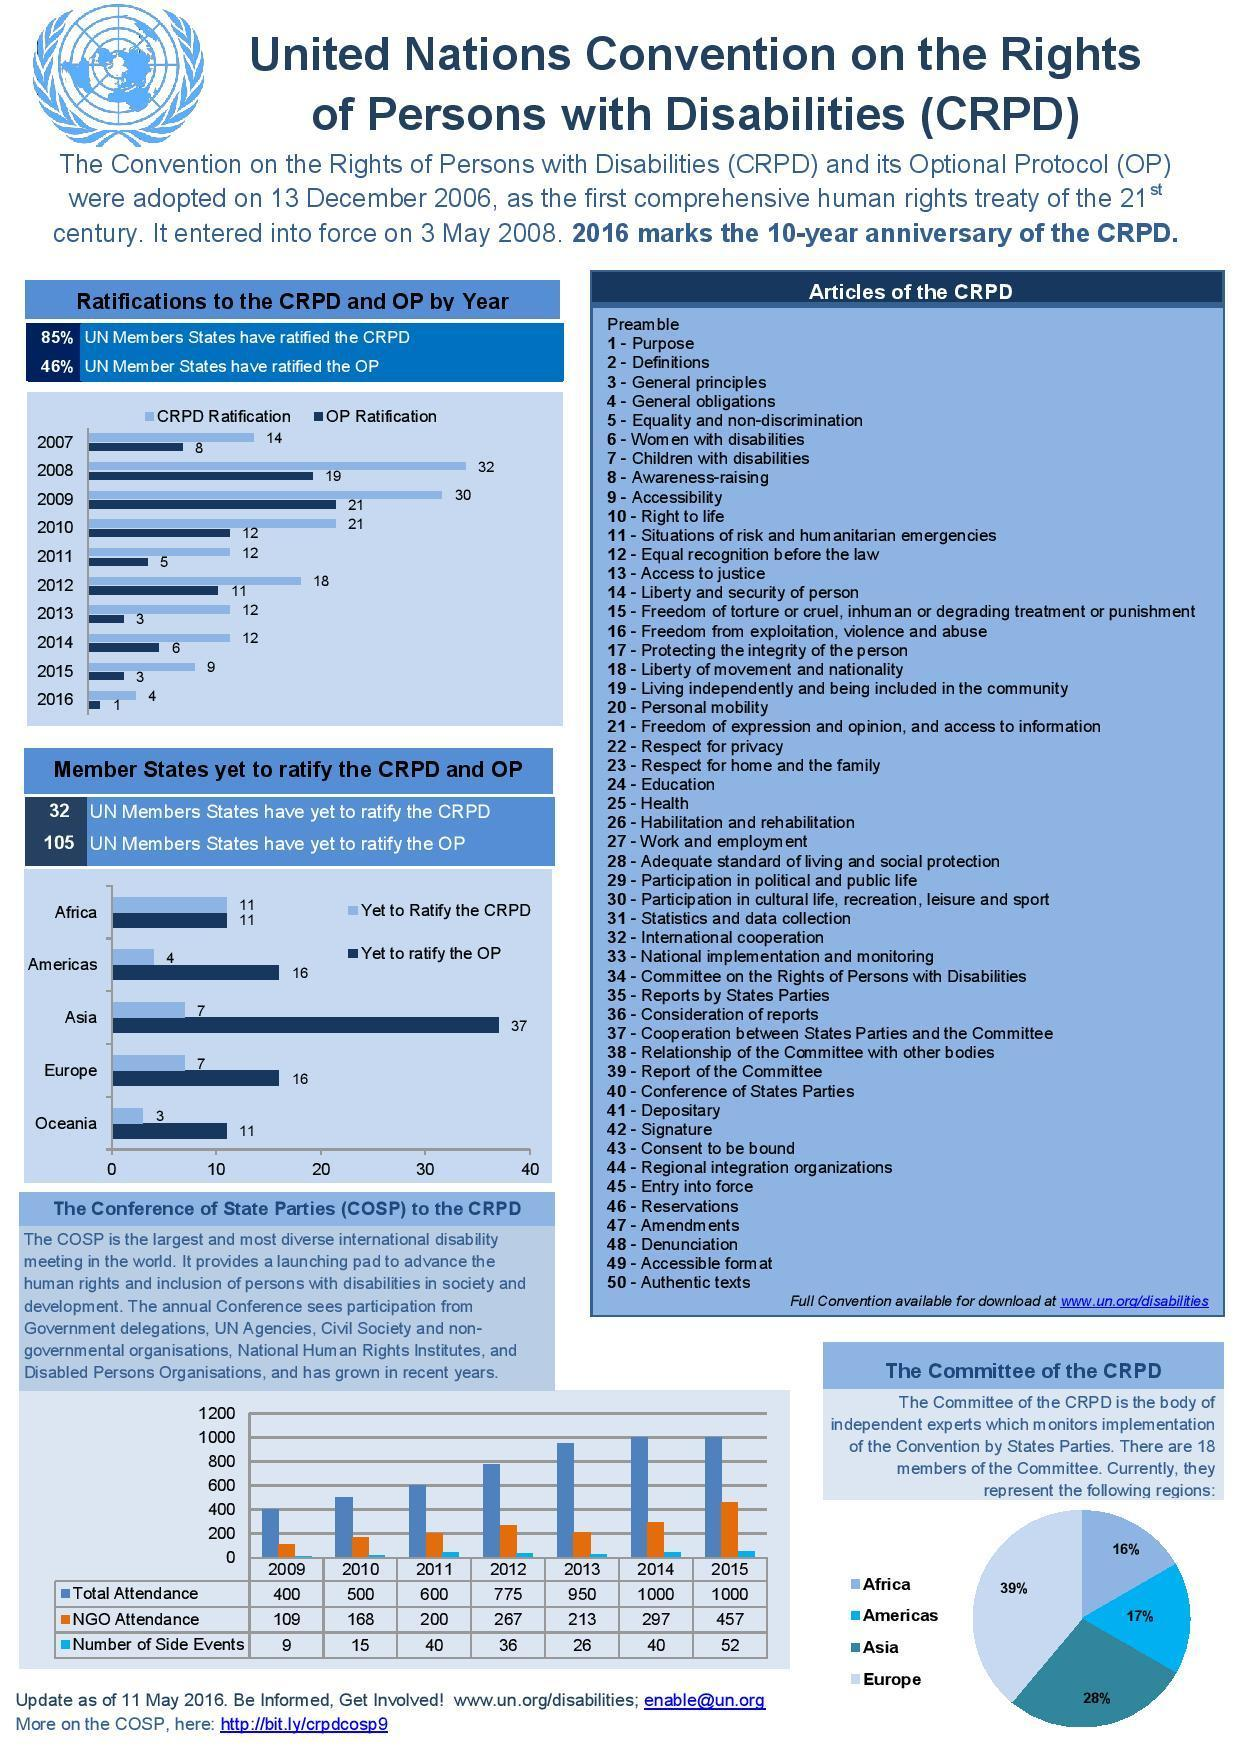In which year was the NGO attendance above 400?
Answer the question with a short phrase. 2015 Which region is second in leading at the Committee of the CPRD? Asia How many members in Asia are yet to ratify the OP? 37 How many articles does the CPRD have including the Preamble? 51 In which year was OP ratification the least? 2016 In which year was CPRD ratification highest? 2008 Which year saw the total attendance go below 500? 2009 How many members in Europe have not yet ratified the CPRD? 16 